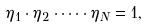<formula> <loc_0><loc_0><loc_500><loc_500>\eta _ { 1 } \cdot \eta _ { 2 } \cdot \dots \cdot \eta _ { N } = 1 ,</formula> 